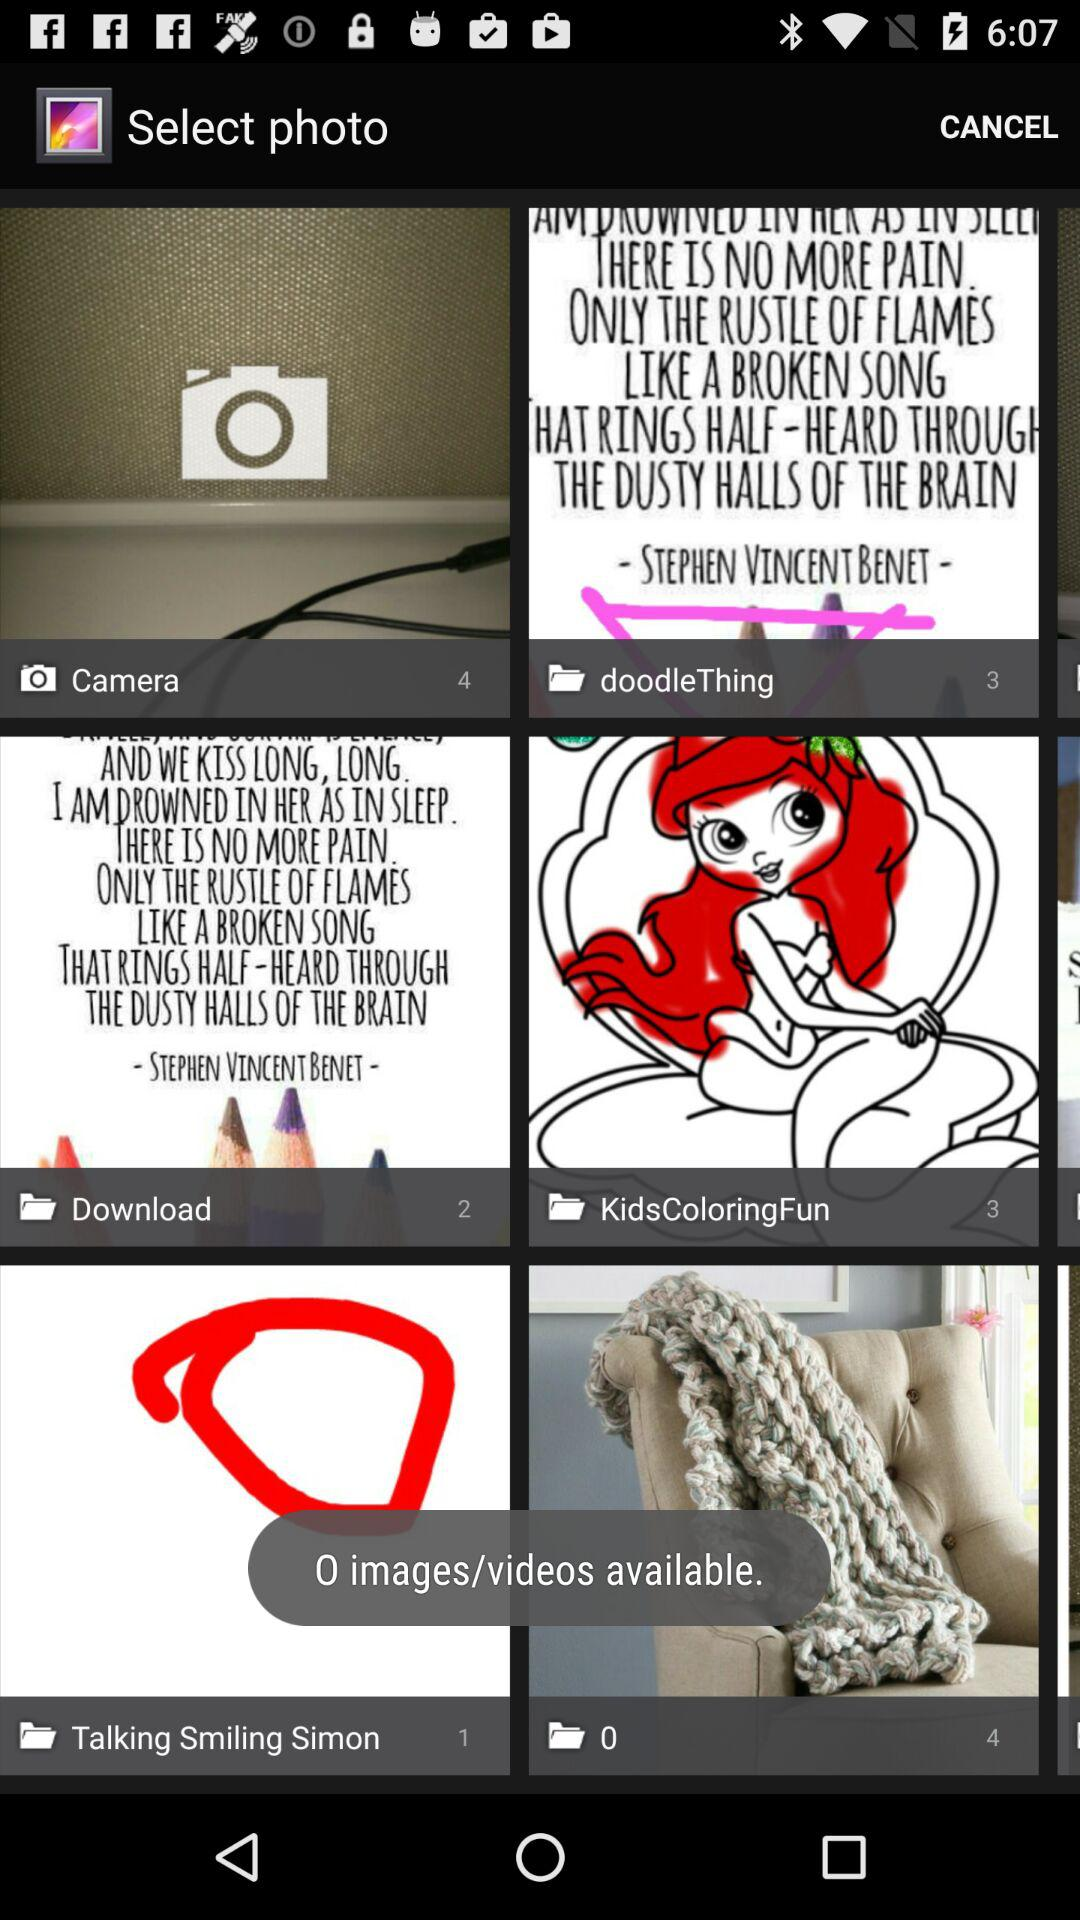How many images are in the "Camera" folder? There are 4 images in the "Camera" folder. 